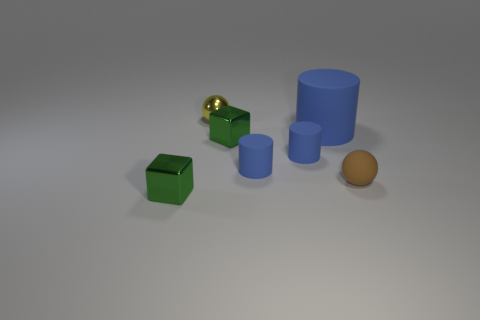Add 3 large rubber cylinders. How many objects exist? 10 Subtract all cubes. How many objects are left? 5 Subtract all matte things. Subtract all green objects. How many objects are left? 1 Add 6 small metal cubes. How many small metal cubes are left? 8 Add 6 green blocks. How many green blocks exist? 8 Subtract 0 purple cubes. How many objects are left? 7 